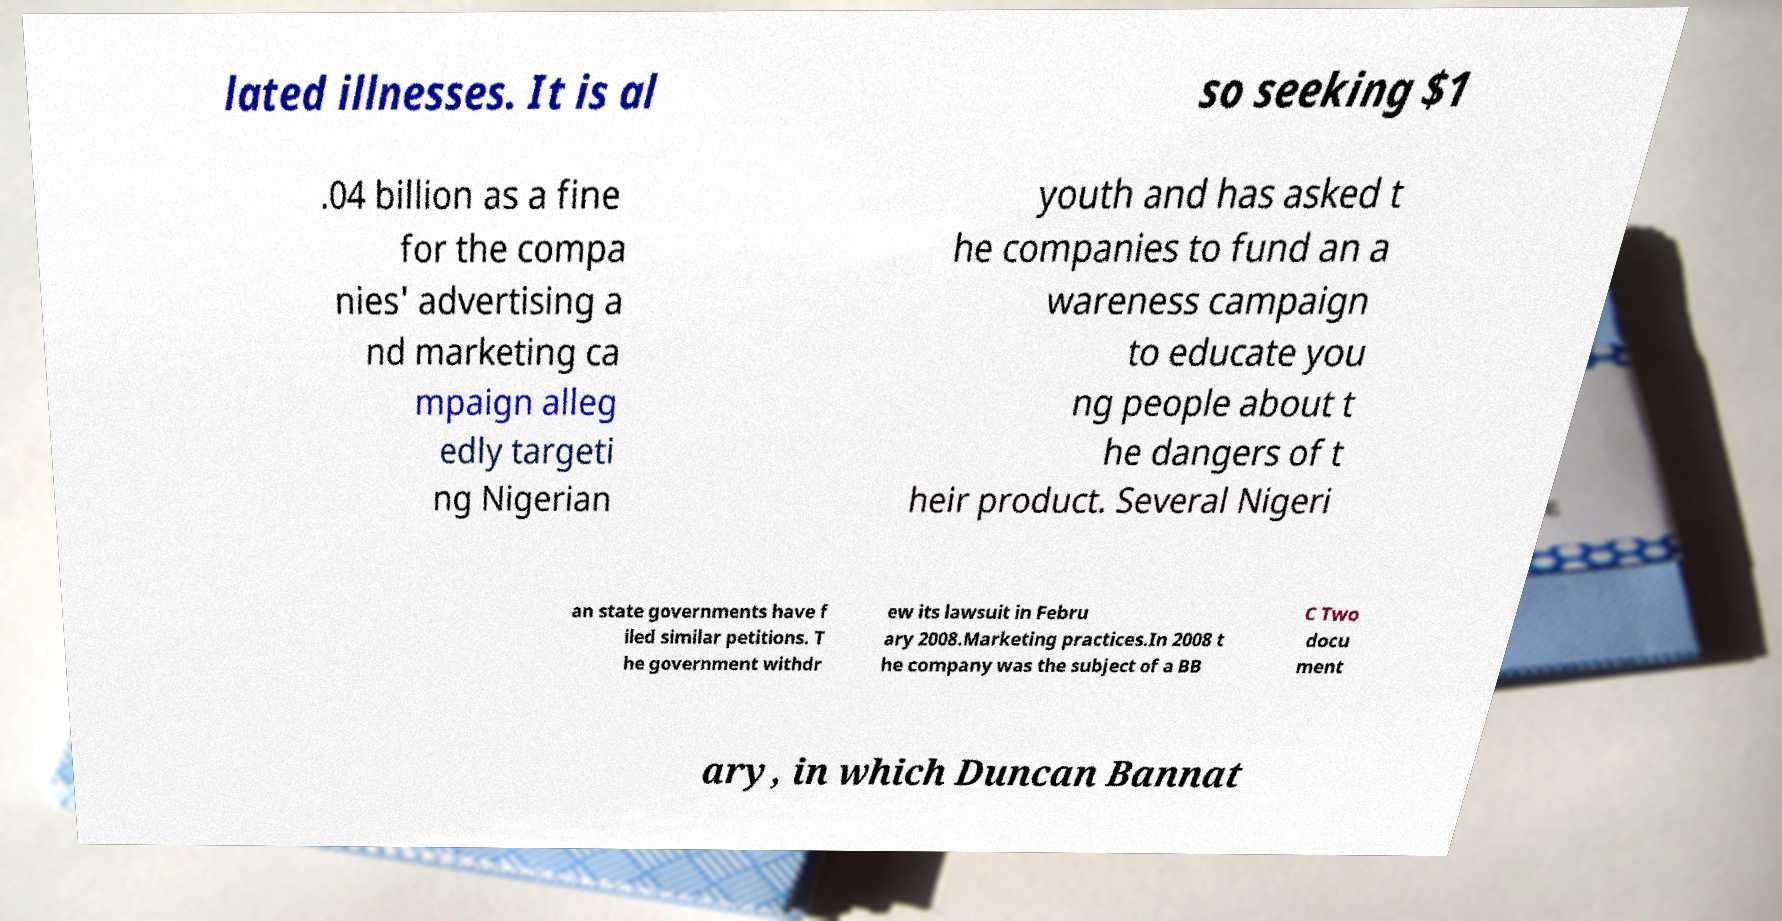Please read and relay the text visible in this image. What does it say? lated illnesses. It is al so seeking $1 .04 billion as a fine for the compa nies' advertising a nd marketing ca mpaign alleg edly targeti ng Nigerian youth and has asked t he companies to fund an a wareness campaign to educate you ng people about t he dangers of t heir product. Several Nigeri an state governments have f iled similar petitions. T he government withdr ew its lawsuit in Febru ary 2008.Marketing practices.In 2008 t he company was the subject of a BB C Two docu ment ary, in which Duncan Bannat 